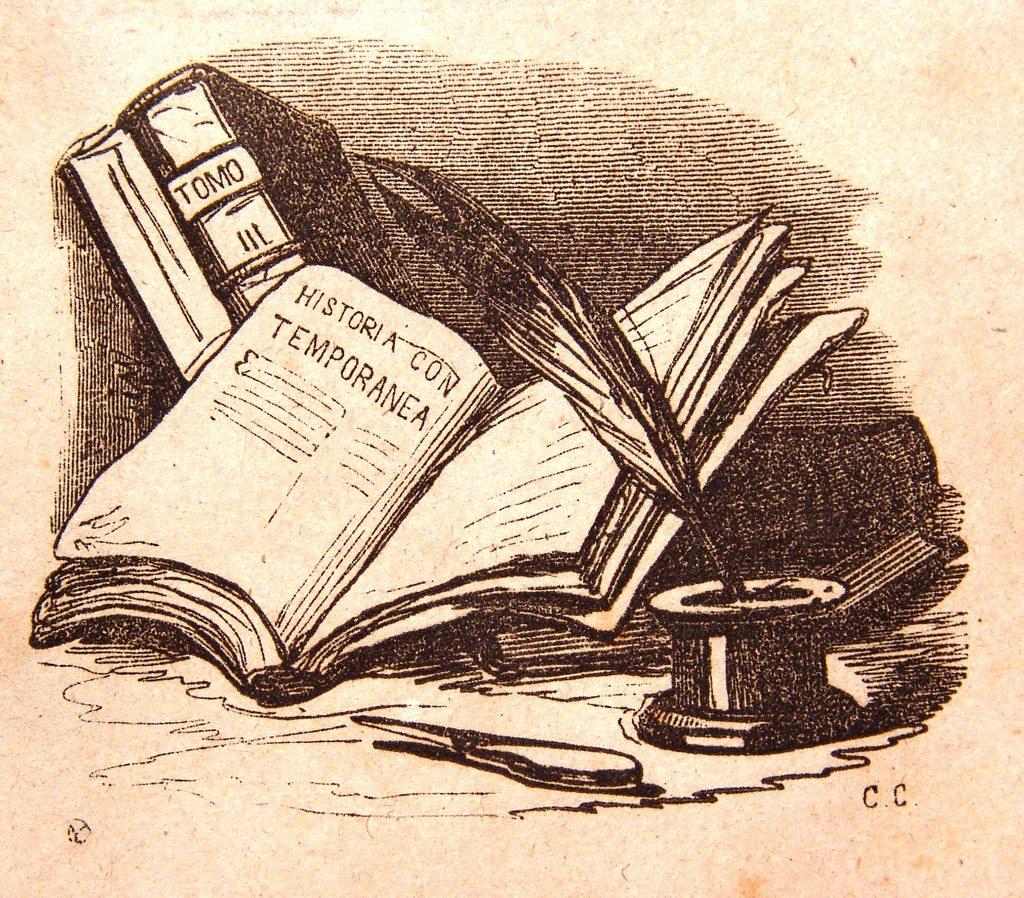What kind of history is mentioned?
Offer a very short reply. Temporanea. Is the text written in english?
Your answer should be compact. No. 